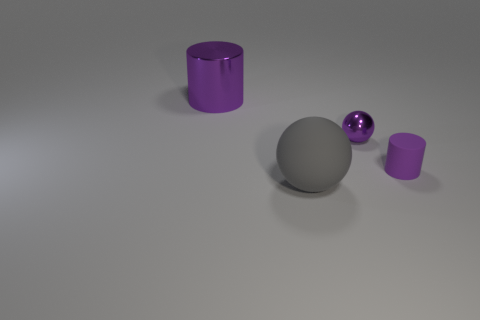Add 3 purple metal balls. How many objects exist? 7 Add 4 big blue things. How many big blue things exist? 4 Subtract 0 gray cubes. How many objects are left? 4 Subtract 1 balls. How many balls are left? 1 Subtract all yellow cylinders. Subtract all brown cubes. How many cylinders are left? 2 Subtract all gray cylinders. How many yellow balls are left? 0 Subtract all tiny purple shiny balls. Subtract all tiny rubber objects. How many objects are left? 2 Add 4 matte spheres. How many matte spheres are left? 5 